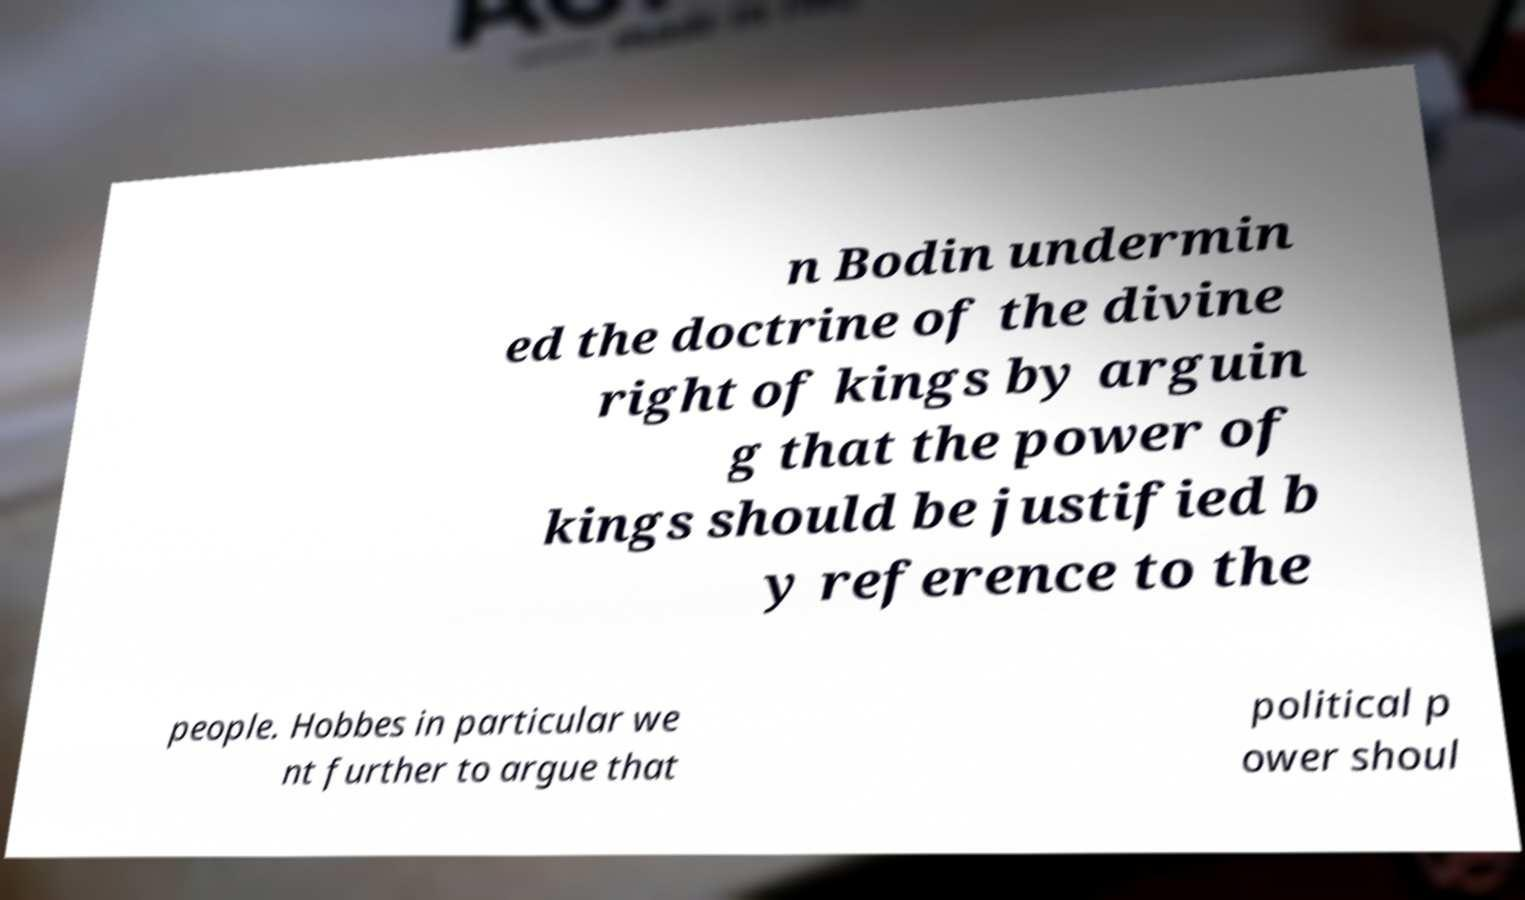For documentation purposes, I need the text within this image transcribed. Could you provide that? n Bodin undermin ed the doctrine of the divine right of kings by arguin g that the power of kings should be justified b y reference to the people. Hobbes in particular we nt further to argue that political p ower shoul 